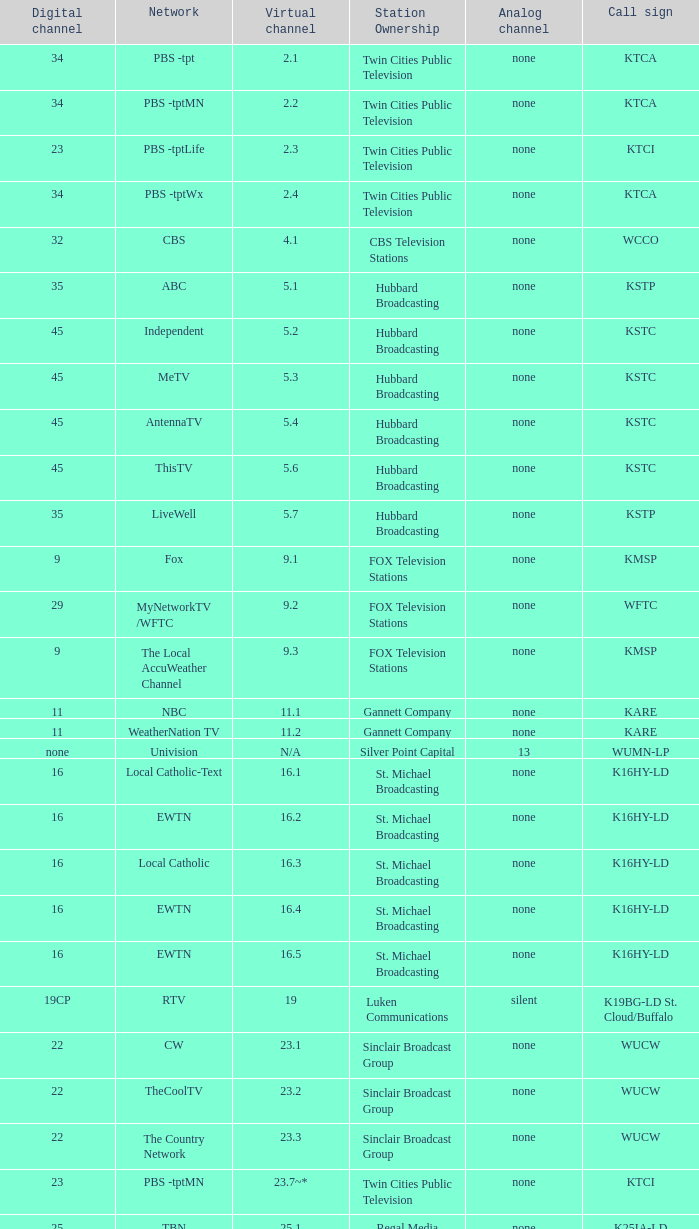Call sign of k33ln-ld, and a Virtual channel of 33.5 is what network? 3ABN Radio-Audio. 